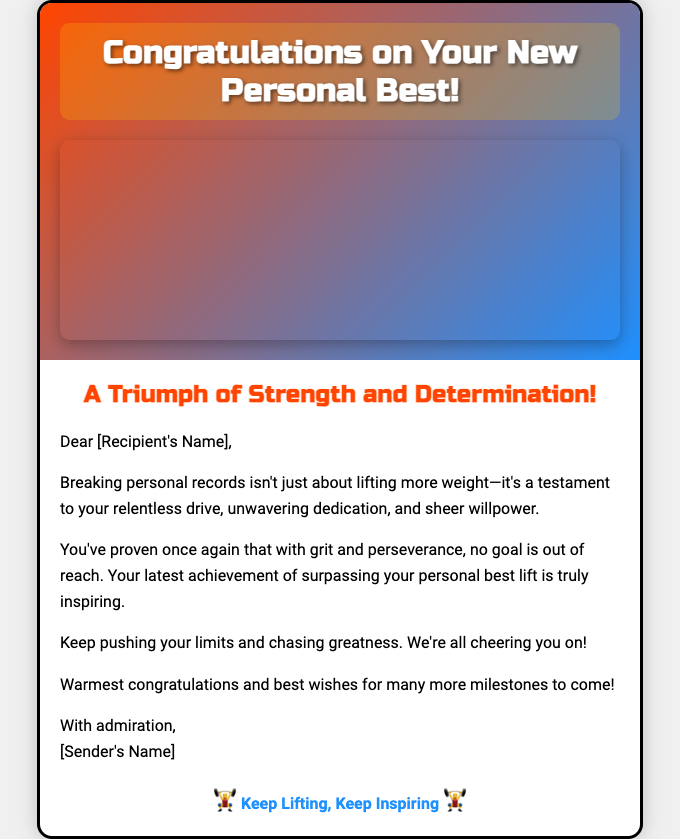What is the title of the card? The title of the card is prominently displayed at the top of the document.
Answer: Congratulations on Your New Personal Best! What visual element is included in the card? The card features a weightlifter raising the bar, as indicated by the description of the image section.
Answer: A weightlifter image Who is the card addressed to? The card includes a placeholder for the recipient's name, indicating it's personalized.
Answer: [Recipient's Name] What message is conveyed in the heading of the inside of the card? The heading in the inside section summarizes the theme of achievement and strength.
Answer: A Triumph of Strength and Determination! What symbol is found in the footer of the card? The footer includes a graphic or emoji that symbolizes weightlifting and motivation.
Answer: 🏋️‍♂️ How many personal qualities are highlighted as part of the achievement? The text emphasizes three qualities that contributed to the achievement.
Answer: Three qualities (relentless drive, unwavering dedication, sheer willpower) What is the sender's intention towards the recipient's future efforts? The closing remarks express encouragement for the recipient to continue striving for greatness.
Answer: Best wishes for many more milestones to come! What is the primary color gradient used in the card’s front design? The gradient consists of two vibrant colors that set an energetic tone for the card.
Answer: Orange to Blue 